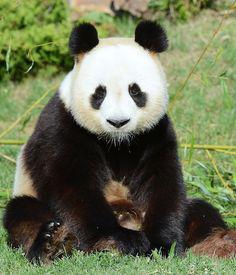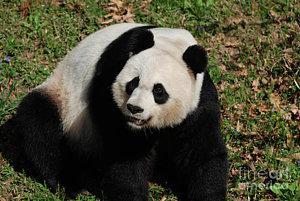The first image is the image on the left, the second image is the image on the right. Given the left and right images, does the statement "The right image contains a panda with bamboo in its mouth." hold true? Answer yes or no. No. The first image is the image on the left, the second image is the image on the right. Considering the images on both sides, is "All pandas are sitting up, and at least one panda is munching on plant material grasped in one paw." valid? Answer yes or no. No. 